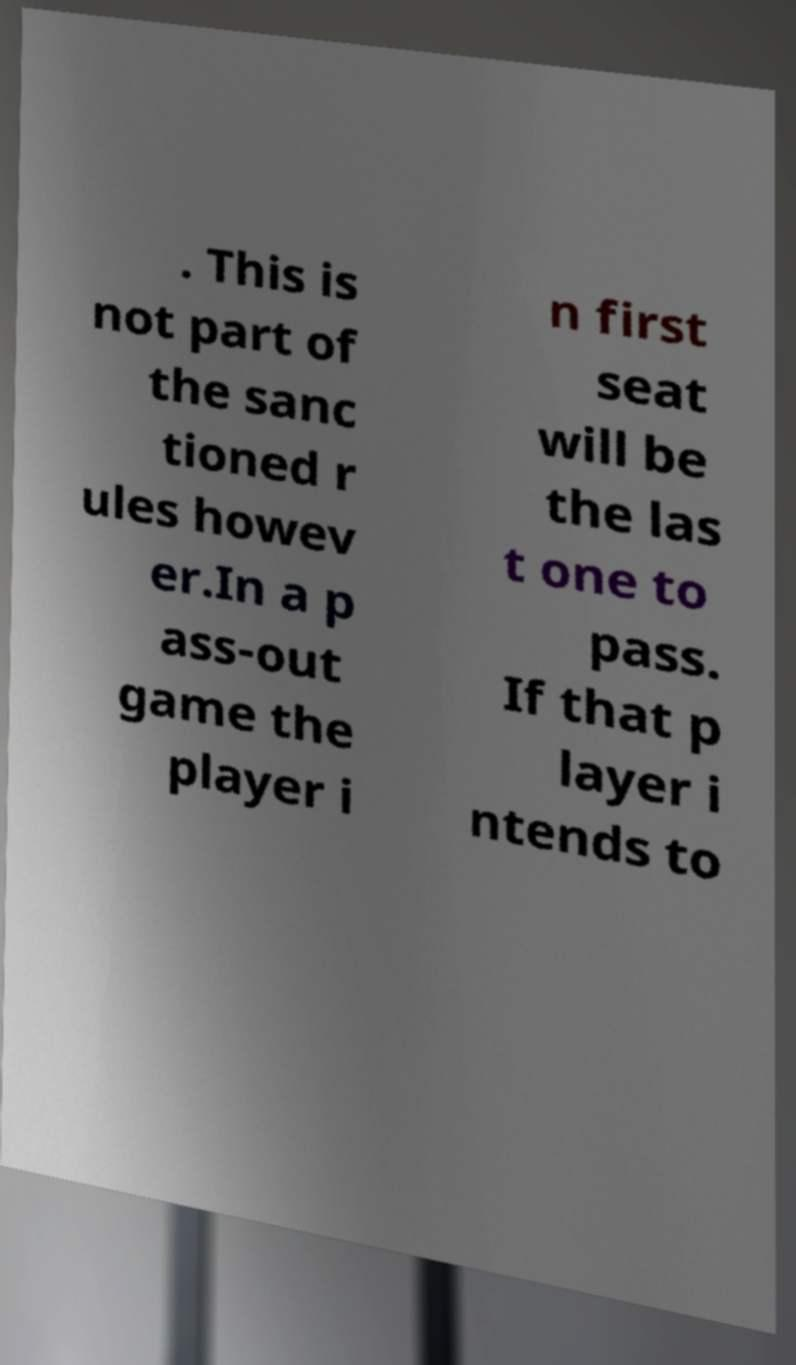Could you assist in decoding the text presented in this image and type it out clearly? . This is not part of the sanc tioned r ules howev er.In a p ass-out game the player i n first seat will be the las t one to pass. If that p layer i ntends to 